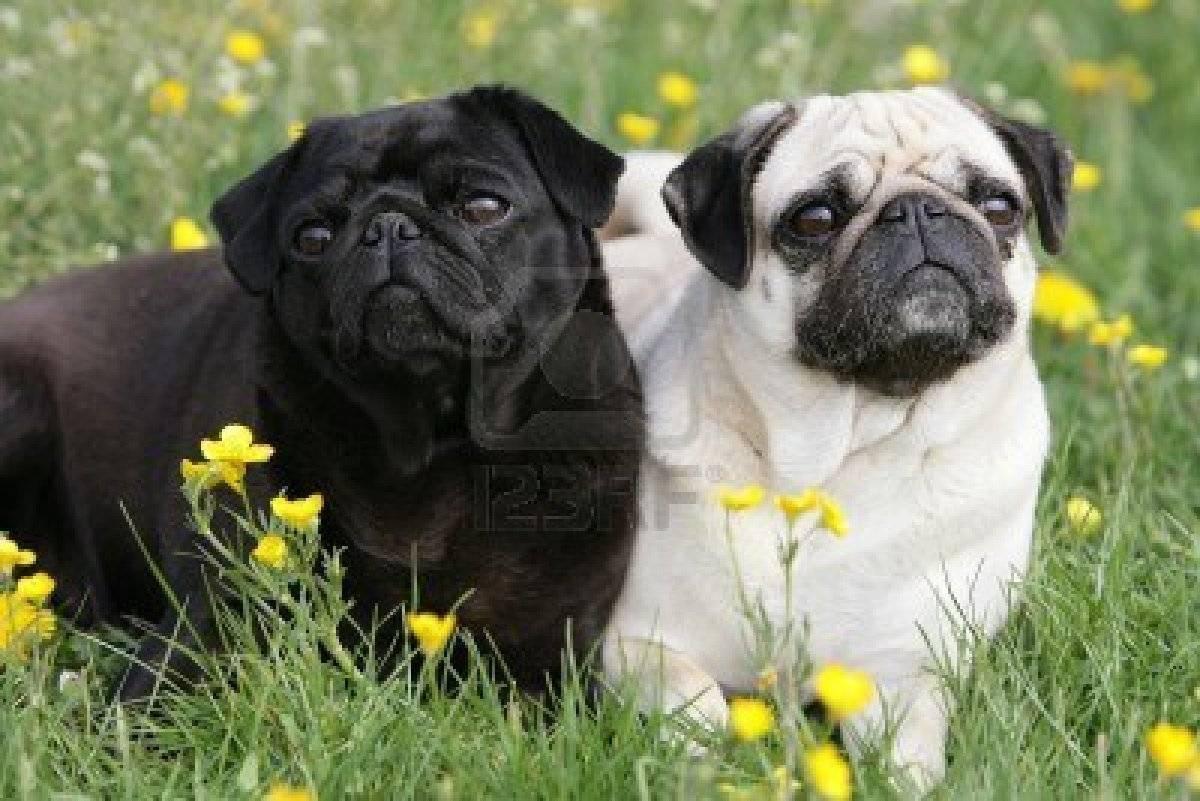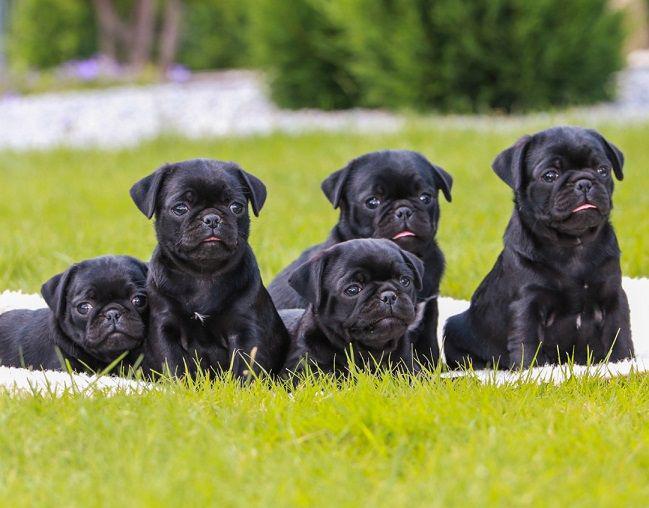The first image is the image on the left, the second image is the image on the right. Assess this claim about the two images: "In one image there is one black pug and at least one flower visible". Correct or not? Answer yes or no. Yes. The first image is the image on the left, the second image is the image on the right. Considering the images on both sides, is "An image features two different-colored pug dogs posing together in the grass." valid? Answer yes or no. Yes. 